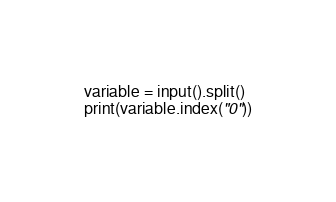<code> <loc_0><loc_0><loc_500><loc_500><_Python_>variable = input().split()
print(variable.index("0"))</code> 